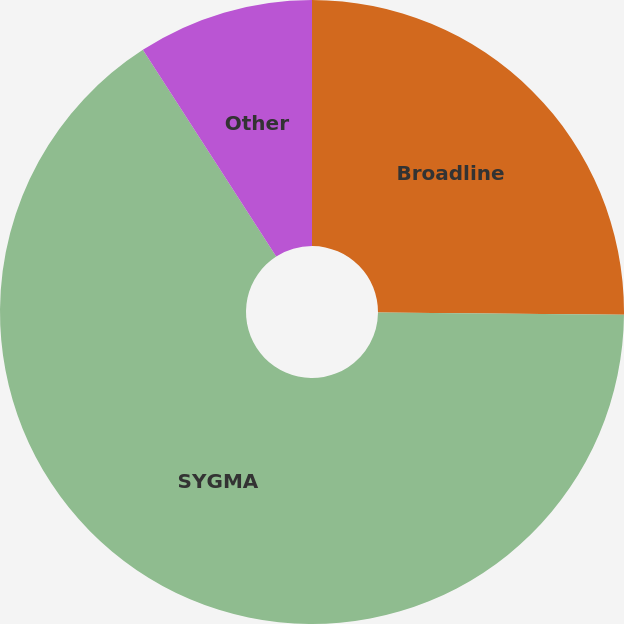Convert chart. <chart><loc_0><loc_0><loc_500><loc_500><pie_chart><fcel>Broadline<fcel>SYGMA<fcel>Other<nl><fcel>25.14%<fcel>65.75%<fcel>9.12%<nl></chart> 